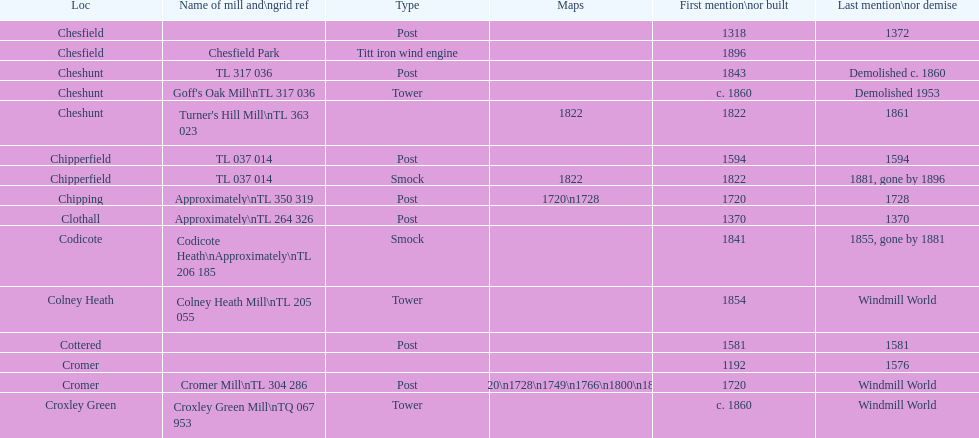What location has the most maps? Cromer. 